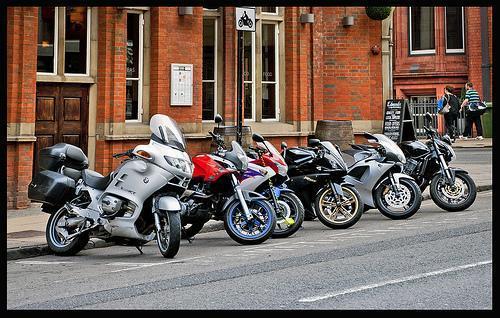How many motorcycles can be seen?
Give a very brief answer. 6. How many people are seen?
Give a very brief answer. 2. 